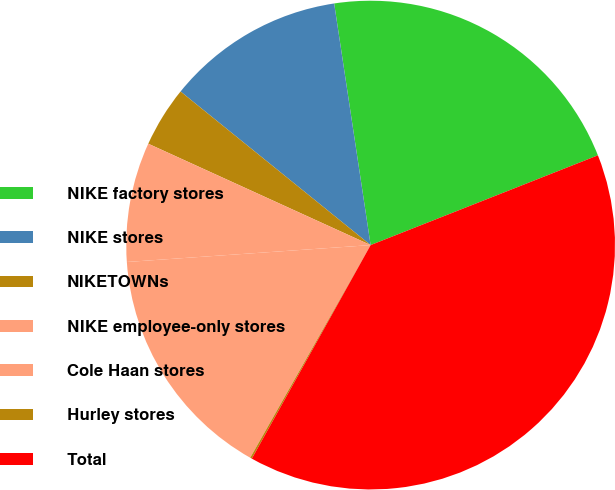<chart> <loc_0><loc_0><loc_500><loc_500><pie_chart><fcel>NIKE factory stores<fcel>NIKE stores<fcel>NIKETOWNs<fcel>NIKE employee-only stores<fcel>Cole Haan stores<fcel>Hurley stores<fcel>Total<nl><fcel>21.4%<fcel>11.8%<fcel>4.01%<fcel>7.91%<fcel>15.7%<fcel>0.12%<fcel>39.07%<nl></chart> 